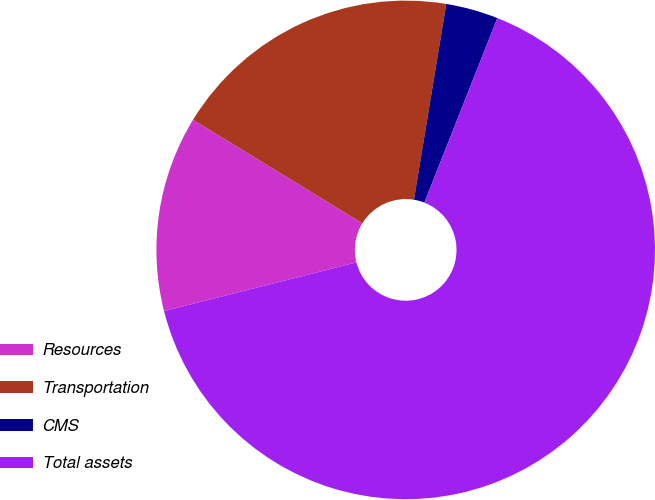Convert chart to OTSL. <chart><loc_0><loc_0><loc_500><loc_500><pie_chart><fcel>Resources<fcel>Transportation<fcel>CMS<fcel>Total assets<nl><fcel>12.69%<fcel>18.86%<fcel>3.39%<fcel>65.05%<nl></chart> 